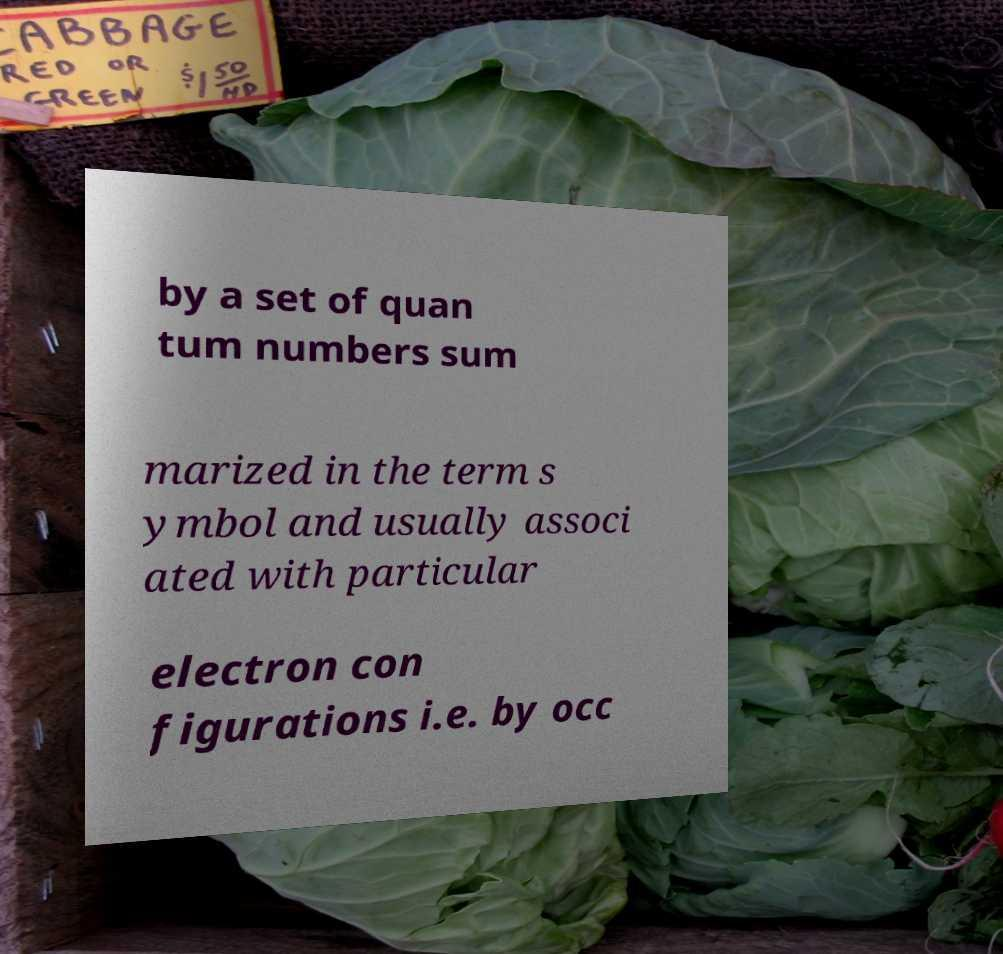There's text embedded in this image that I need extracted. Can you transcribe it verbatim? by a set of quan tum numbers sum marized in the term s ymbol and usually associ ated with particular electron con figurations i.e. by occ 